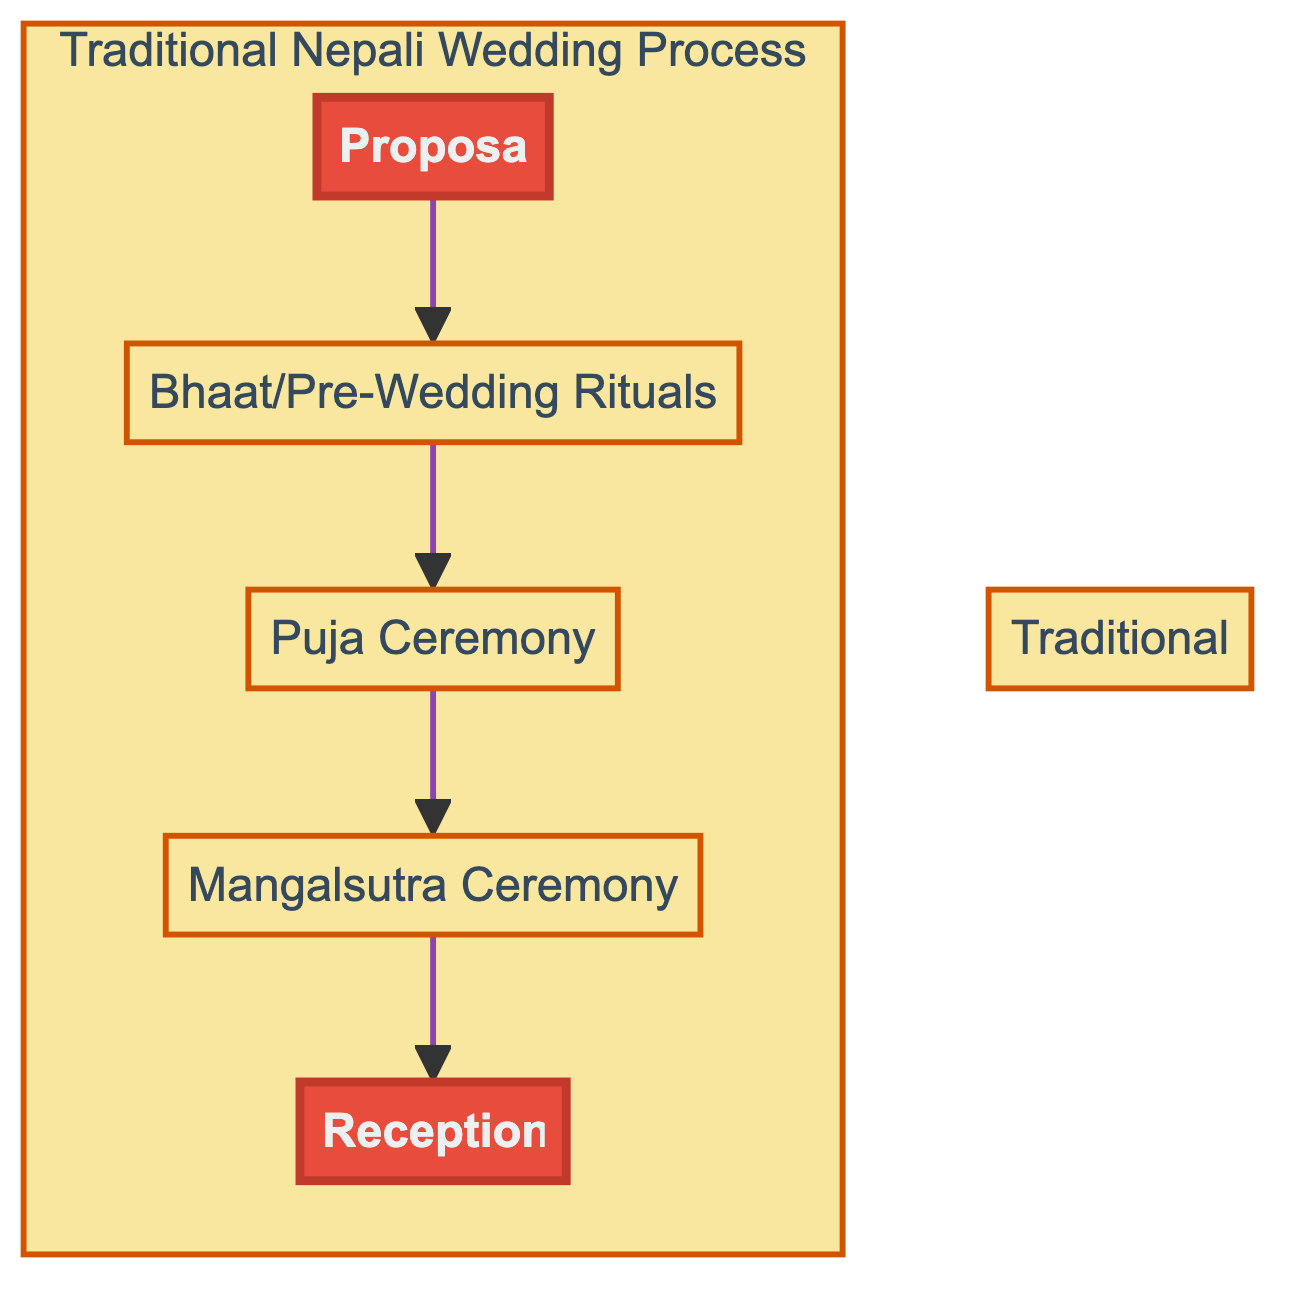What is the first step in the wedding process? The flow chart illustrates the order of the wedding process starting with the "Proposal" as the first step in the sequence.
Answer: Proposal How many major steps are in the wedding process? The diagram depicts a total of five distinct elements, which represent the major steps in the traditional Nepali wedding process.
Answer: 5 What follows the "Bhaat/Pre-Wedding Rituals"? According to the flow, the next step after "Bhaat/Pre-Wedding Rituals" is the "Puja Ceremony," which is the ritual that follows.
Answer: Puja Ceremony What is symbolized by the "Mangalsutra Ceremony"? The "Mangalsutra Ceremony" is represented as the moment when the groom ties a sacred thread around the bride's neck, symbolizing their union.
Answer: Their union What two steps are highlighted in the diagram? The diagram highlights the "Proposal" at the beginning and the "Reception" at the end, indicating these are significant points in the process.
Answer: Proposal, Reception Which step directly leads to the "Reception"? The flow indicates that the step that directly leads to the "Reception" is the "Mangalsutra Ceremony," establishing this as the preceding action.
Answer: Mangalsutra Ceremony What is the purpose of the "Puja Ceremony"? The "Puja Ceremony" serves the purpose of invoking blessings from deities, a key religious aspect of the wedding process illustrated in the chart.
Answer: Invoking blessings from deities What type of ceremony is held after the "Mangalsutra Ceremony"? Following the "Mangalsutra Ceremony," the next event is the "Reception," which is a celebratory feast to honor the newlyweds.
Answer: Reception 